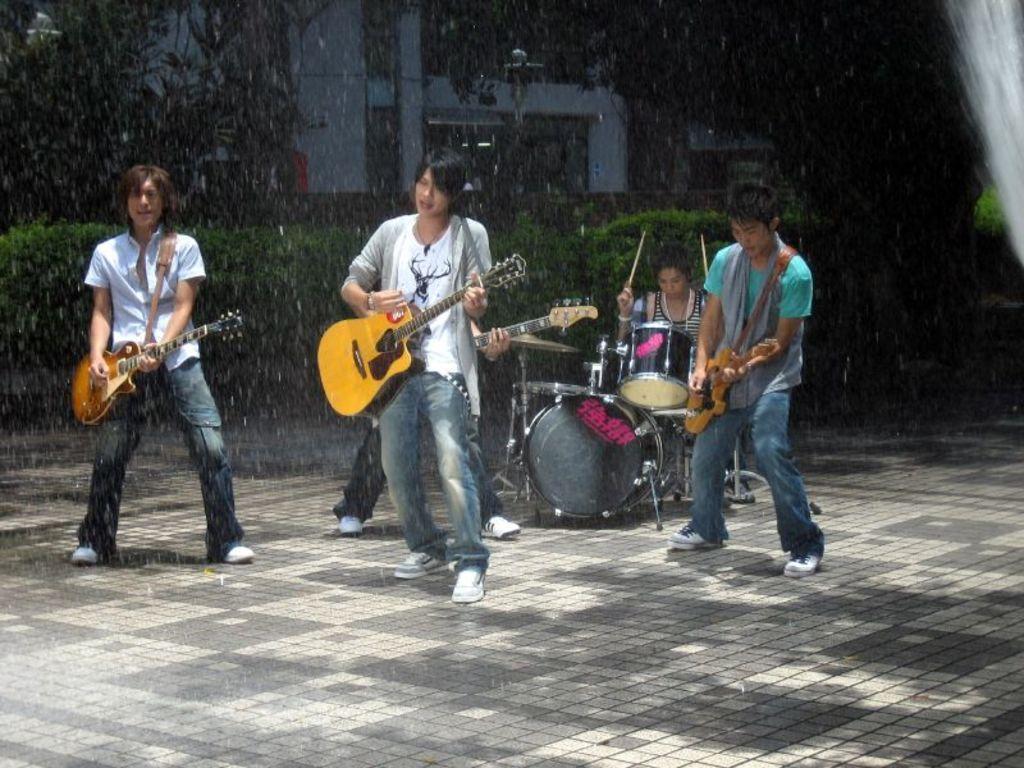Can you describe this image briefly? In this picture we can see three men holding guitars in their hands and playing it and at back of them person playing drums and in background we can see trees, house. 